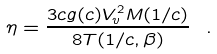Convert formula to latex. <formula><loc_0><loc_0><loc_500><loc_500>\eta = \frac { 3 c g ( c ) V _ { v } ^ { 2 } M ( 1 / c ) } { 8 T ( 1 / c , \beta ) } \ .</formula> 